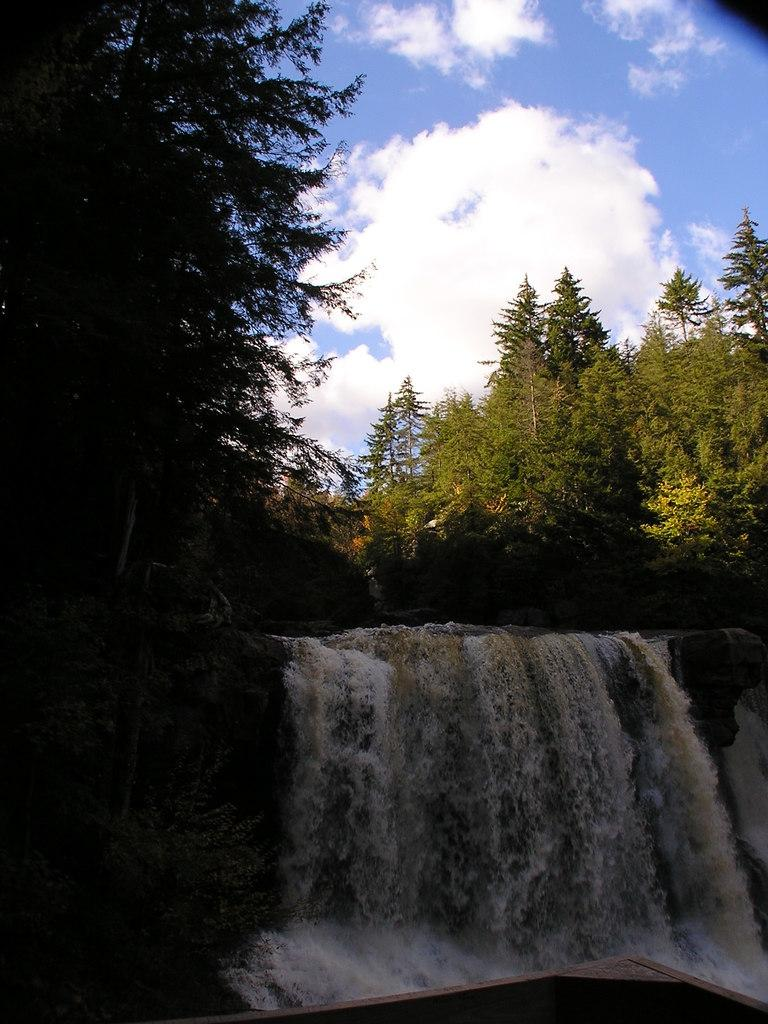What natural feature is the main subject of the image? There is a waterfall in the image. What type of vegetation can be seen in the background of the image? There are trees in the background of the image. What is visible in the sky at the top of the image? Clouds are visible in the sky at the top of the image. What type of loaf can be seen in the image? There is no loaf present in the image. How does the waterfall express disgust in the image? The waterfall does not express any emotions, including disgust, in the image. 